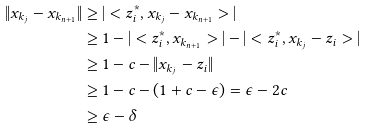Convert formula to latex. <formula><loc_0><loc_0><loc_500><loc_500>\| x _ { k _ { j } } - x _ { k _ { n + 1 } } \| & \geq | < z ^ { * } _ { i } , x _ { k _ { j } } - x _ { k _ { n + 1 } } > | \\ & \geq 1 - | < z ^ { * } _ { i } , x _ { k _ { n + 1 } } > | - | < z ^ { * } _ { i } , x _ { k _ { j } } - z _ { i } > | \\ & \geq 1 - c - \| x _ { k _ { j } } - z _ { i } \| \\ & \geq 1 - c - ( 1 + c - \epsilon ) = \epsilon - 2 c \\ & \geq \epsilon - \delta \\</formula> 